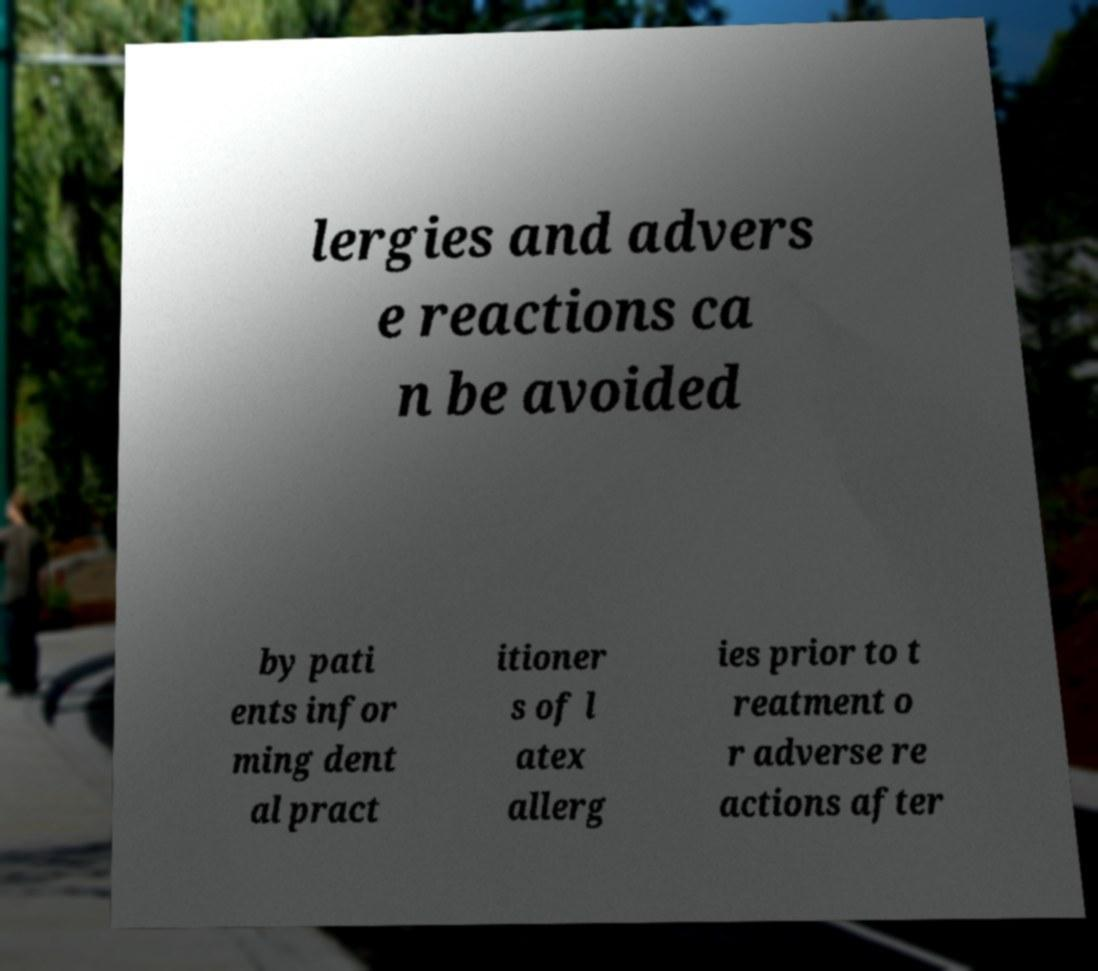What messages or text are displayed in this image? I need them in a readable, typed format. lergies and advers e reactions ca n be avoided by pati ents infor ming dent al pract itioner s of l atex allerg ies prior to t reatment o r adverse re actions after 